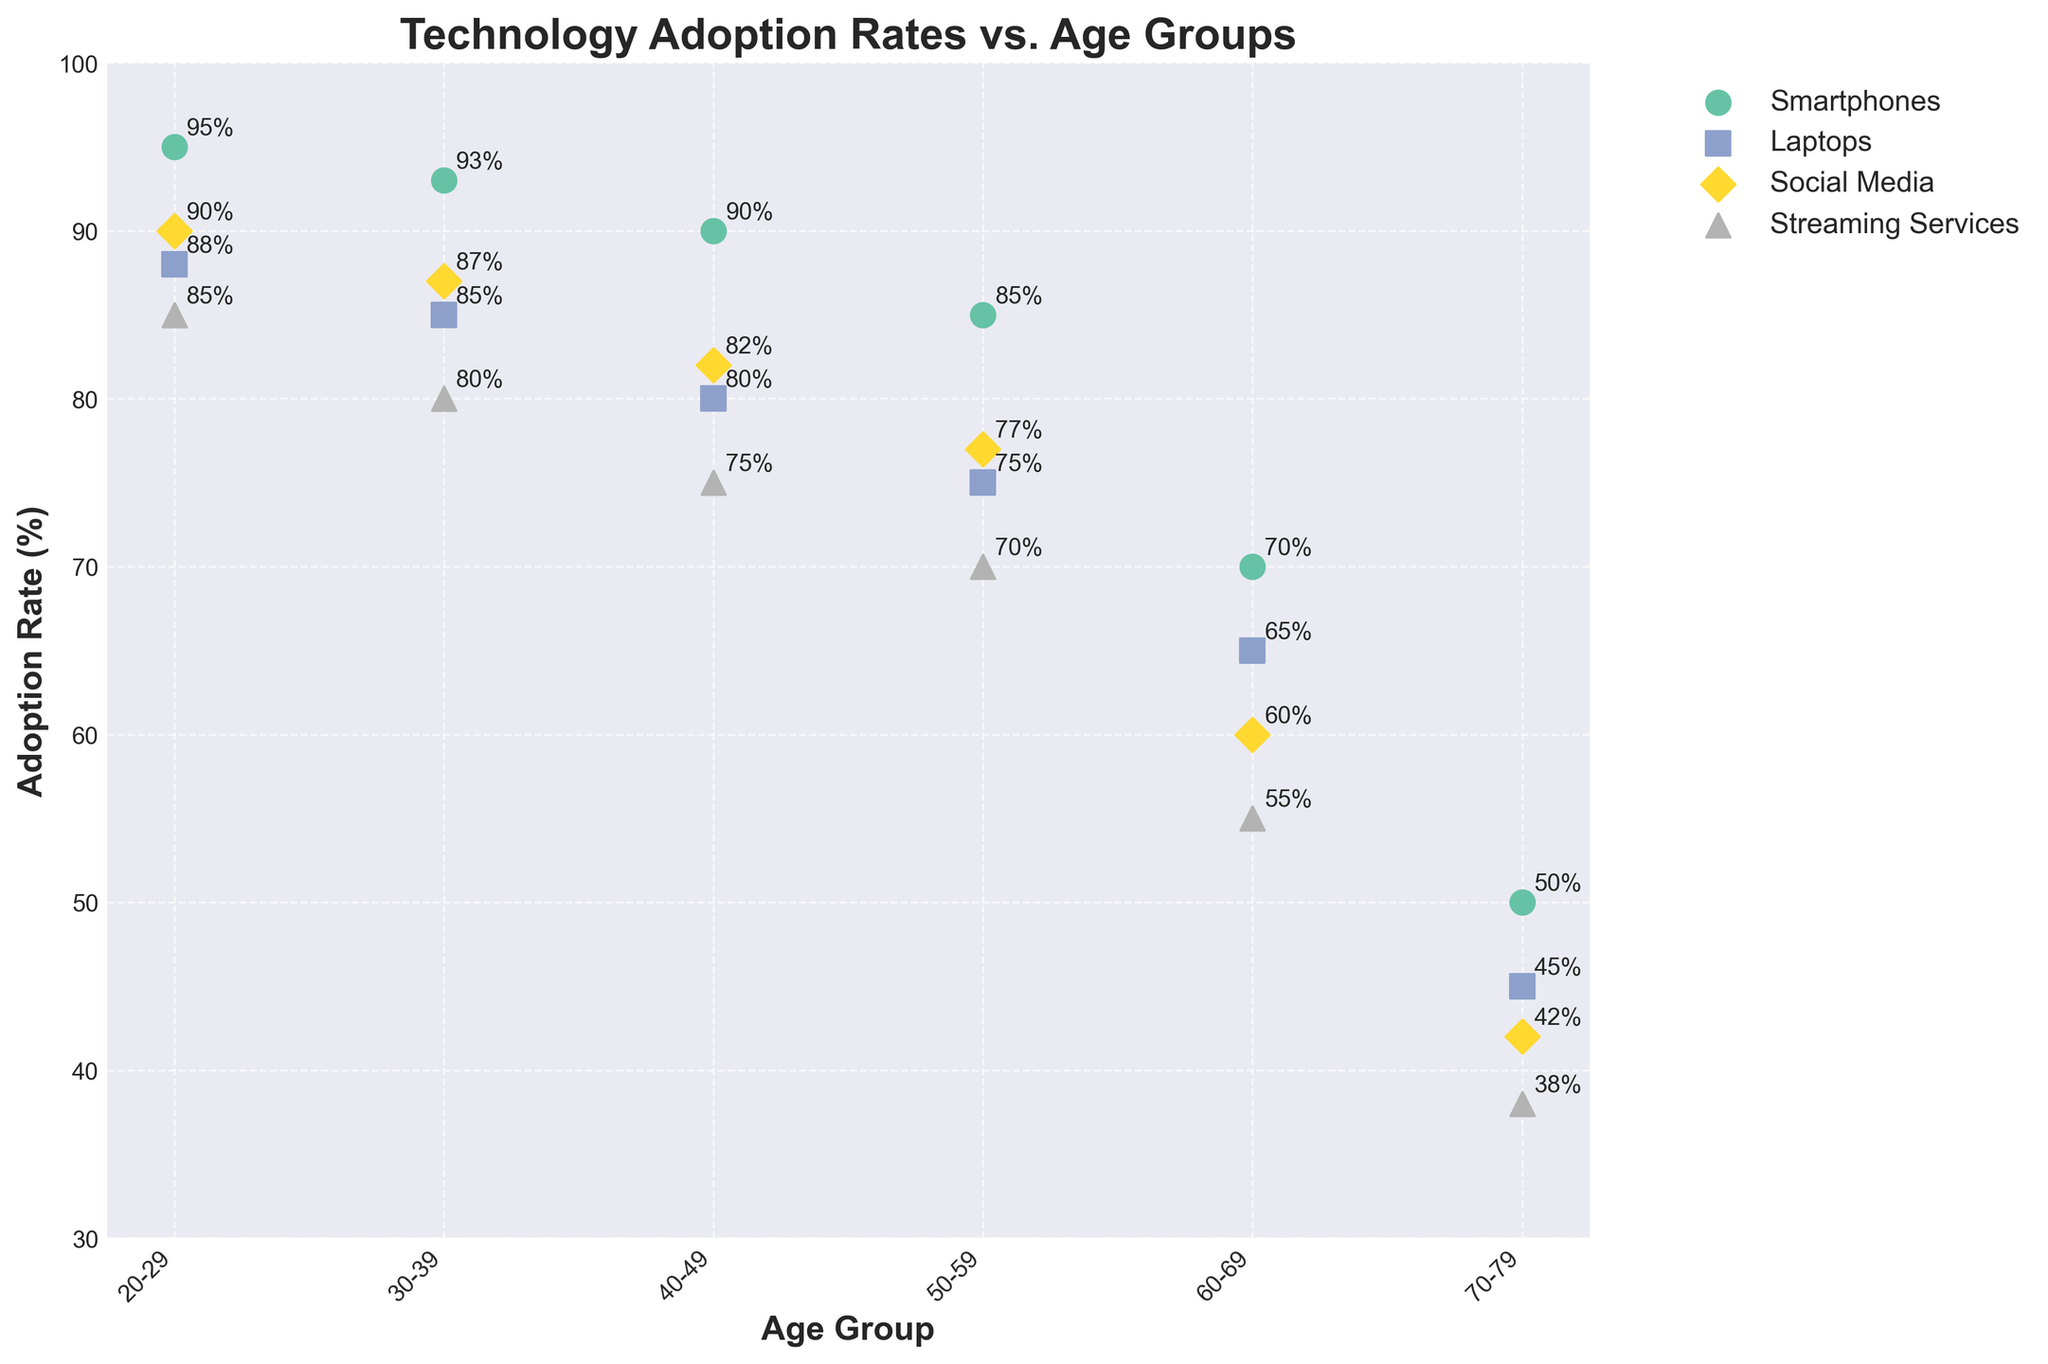What is the title of the figure? The title is typically located at the top of the figure and is usually the largest text.
Answer: Technology Adoption Rates vs. Age Groups How many age groups are included in the figure? You can tell by counting the unique labels along the x-axis representing different age groups.
Answer: 6 What color represents Streaming Services in the scatter plot? You can determine this by observing the legend on the plot which matches colors to technologies.
Answer: Light Green What is the adoption rate of Social Media for the age group 50-59? Look along the x-axis for the age group '50-59', then identify the point labeled 'Social Media' and read the adoption rate from the y-axis.
Answer: 77% Which age group has the lowest adoption rate for Smartphones? Compare all the points labeled 'Smartphones' across different age groups and identify the one with the smallest y-axis value.
Answer: 70-79 What is the difference between the highest and lowest adoption rates for Laptops? Find the highest and lowest y-axis values for points representing Laptops, then calculate the difference. The highest is 88 (from 20-29) and the lowest is 45 (from 70-79).
Answer: 43 Across all age groups, which technology has the most stable adoption rate (less variance)? To identify stability, look for the technology where the points across age groups are the closest in terms of y-axis values.
Answer: Smartphones Compare the adoption rates of Social Media and Streaming Services in the 30-39 age group. Which is higher, and by how much? Locate the points for both 'Social Media' and 'Streaming Services' in the '30-39' age group, then subtract the adoption rate of Streaming Services from Social Media. Social Media is 87 and Streaming Services is 80.
Answer: Social Media by 7% What is the average adoption rate for Smartphones across all age groups? Add up the adoption rates for Smartphones in each age group and divide by the number of age groups (95 + 93 + 90 + 85 + 70 + 50) / 6.
Answer: 80.5% How does the adoption rate of Laptops change from the 20-29 age group to the 70-79 age group? Identify the adoption rates of Laptops in these two age groups and note the difference. For 20-29 it is 88%, for 70-79 it is 45%.
Answer: Decreases by 43% 